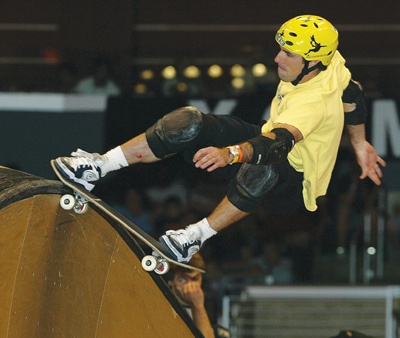Describe the objects in this image and their specific colors. I can see people in black, khaki, and tan tones, skateboard in black, gray, and lightgray tones, people in black, maroon, and olive tones, people in black and teal tones, and people in black and purple tones in this image. 